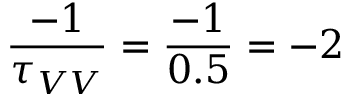Convert formula to latex. <formula><loc_0><loc_0><loc_500><loc_500>\frac { - 1 } { \tau _ { V V } } = \frac { - 1 } { 0 . 5 } = - 2</formula> 